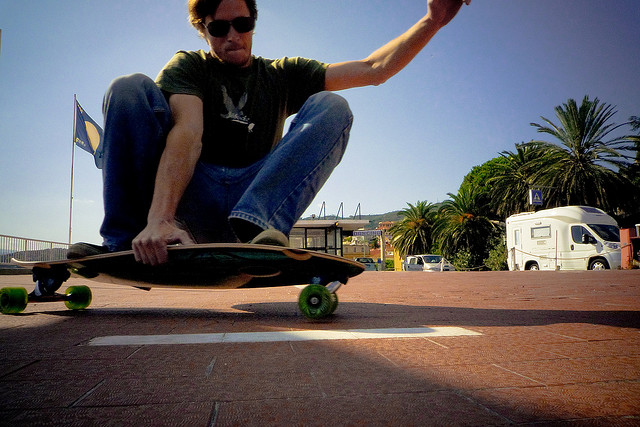<image>Why is the skateboards wheels green? It is ambiguous why the skateboard's wheels are green. It can be for style, customization or to match with the board. Why is the skateboards wheels green? I don't know why the skateboard's wheels are green. It could be to match the board, style, or for customization. 